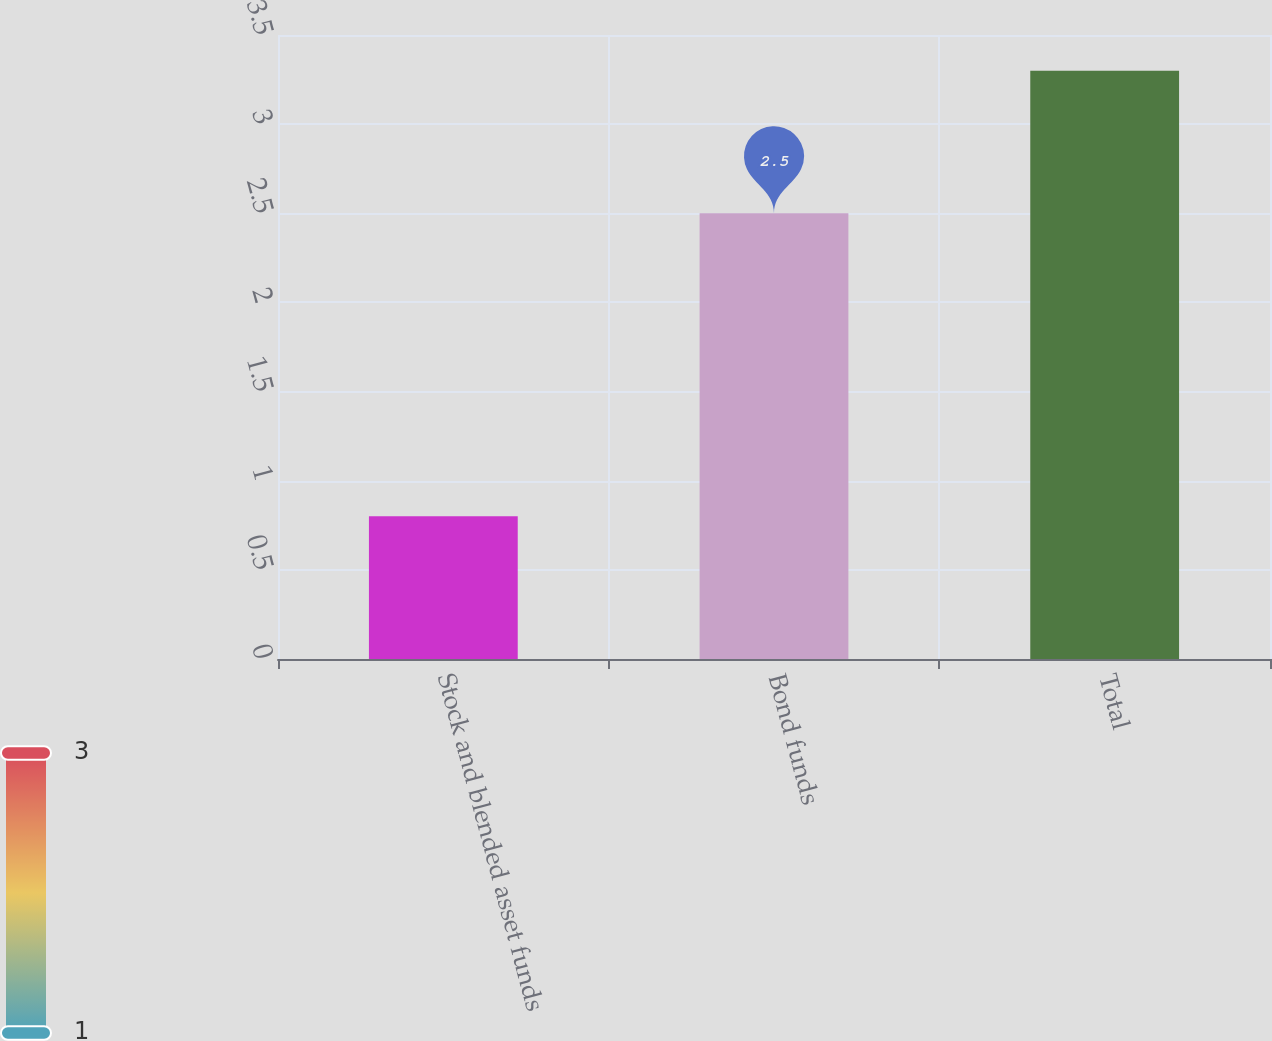Convert chart to OTSL. <chart><loc_0><loc_0><loc_500><loc_500><bar_chart><fcel>Stock and blended asset funds<fcel>Bond funds<fcel>Total<nl><fcel>0.8<fcel>2.5<fcel>3.3<nl></chart> 